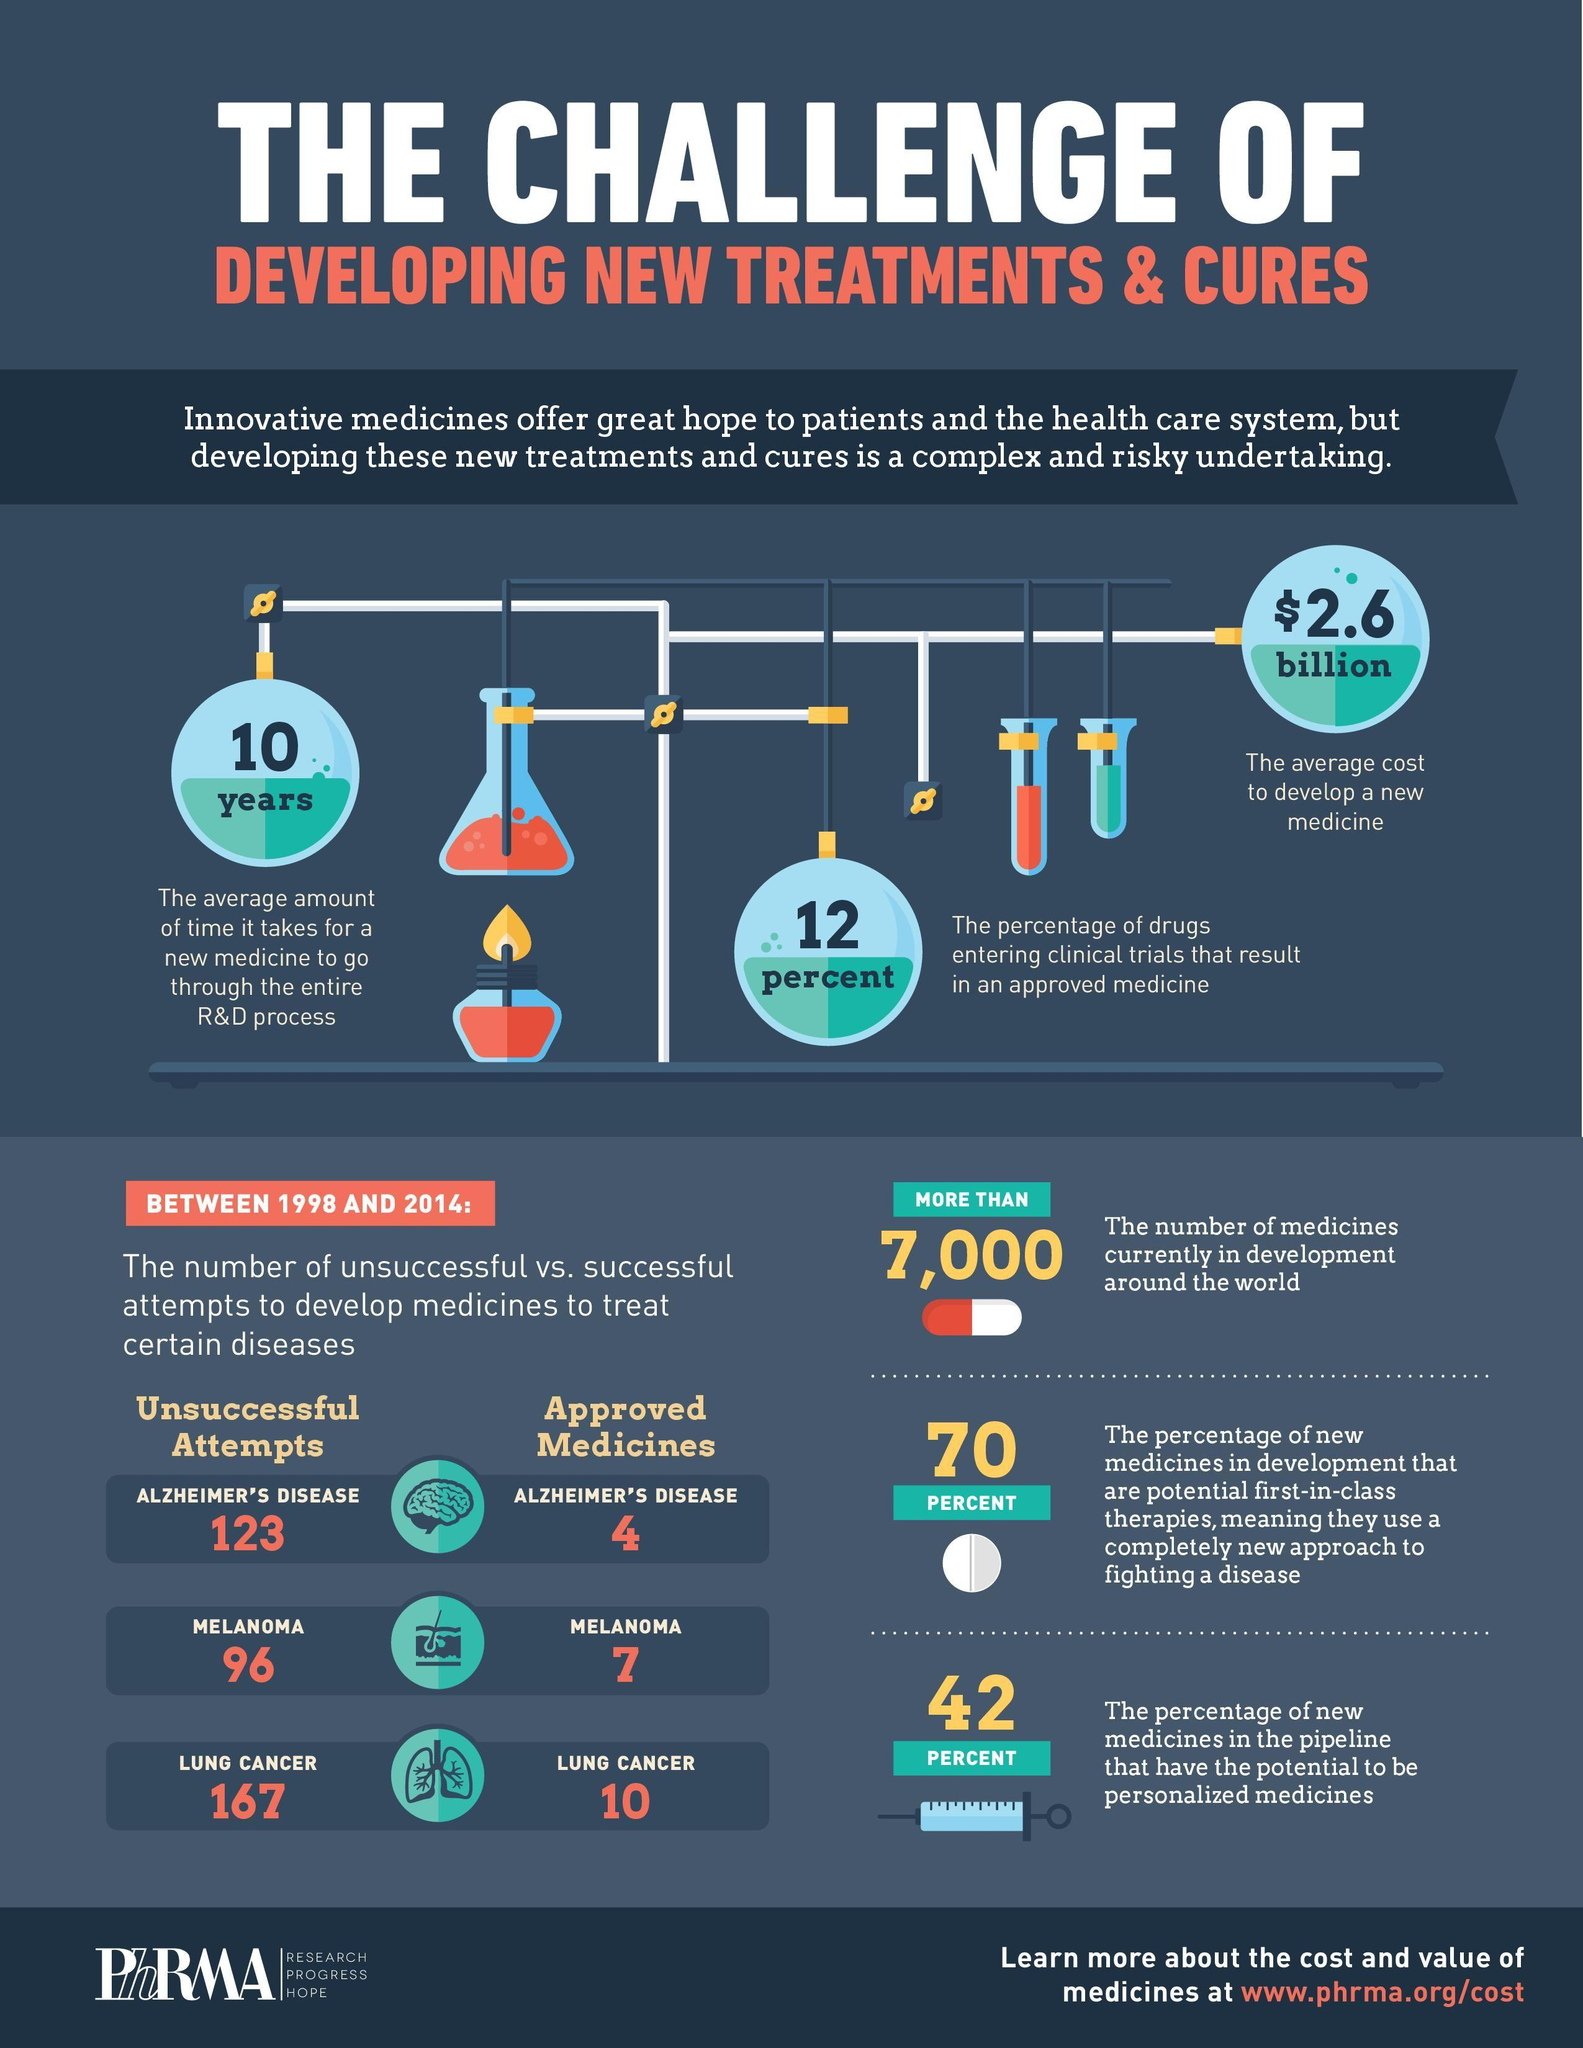Indicate a few pertinent items in this graphic. The R&D process for a new medicine typically takes approximately 10 years to complete. Attempts to develop medicines for Alzheimer's disease, melanoma, and lung cancer have been unsuccessful. Nine-six unsuccessful attempts have been made for melanoma. The average cost to develop a new medicine is estimated to be approximately $2.6 billion. There are approved medicines for Alzheimer's disease, melanoma, and lung cancer. 